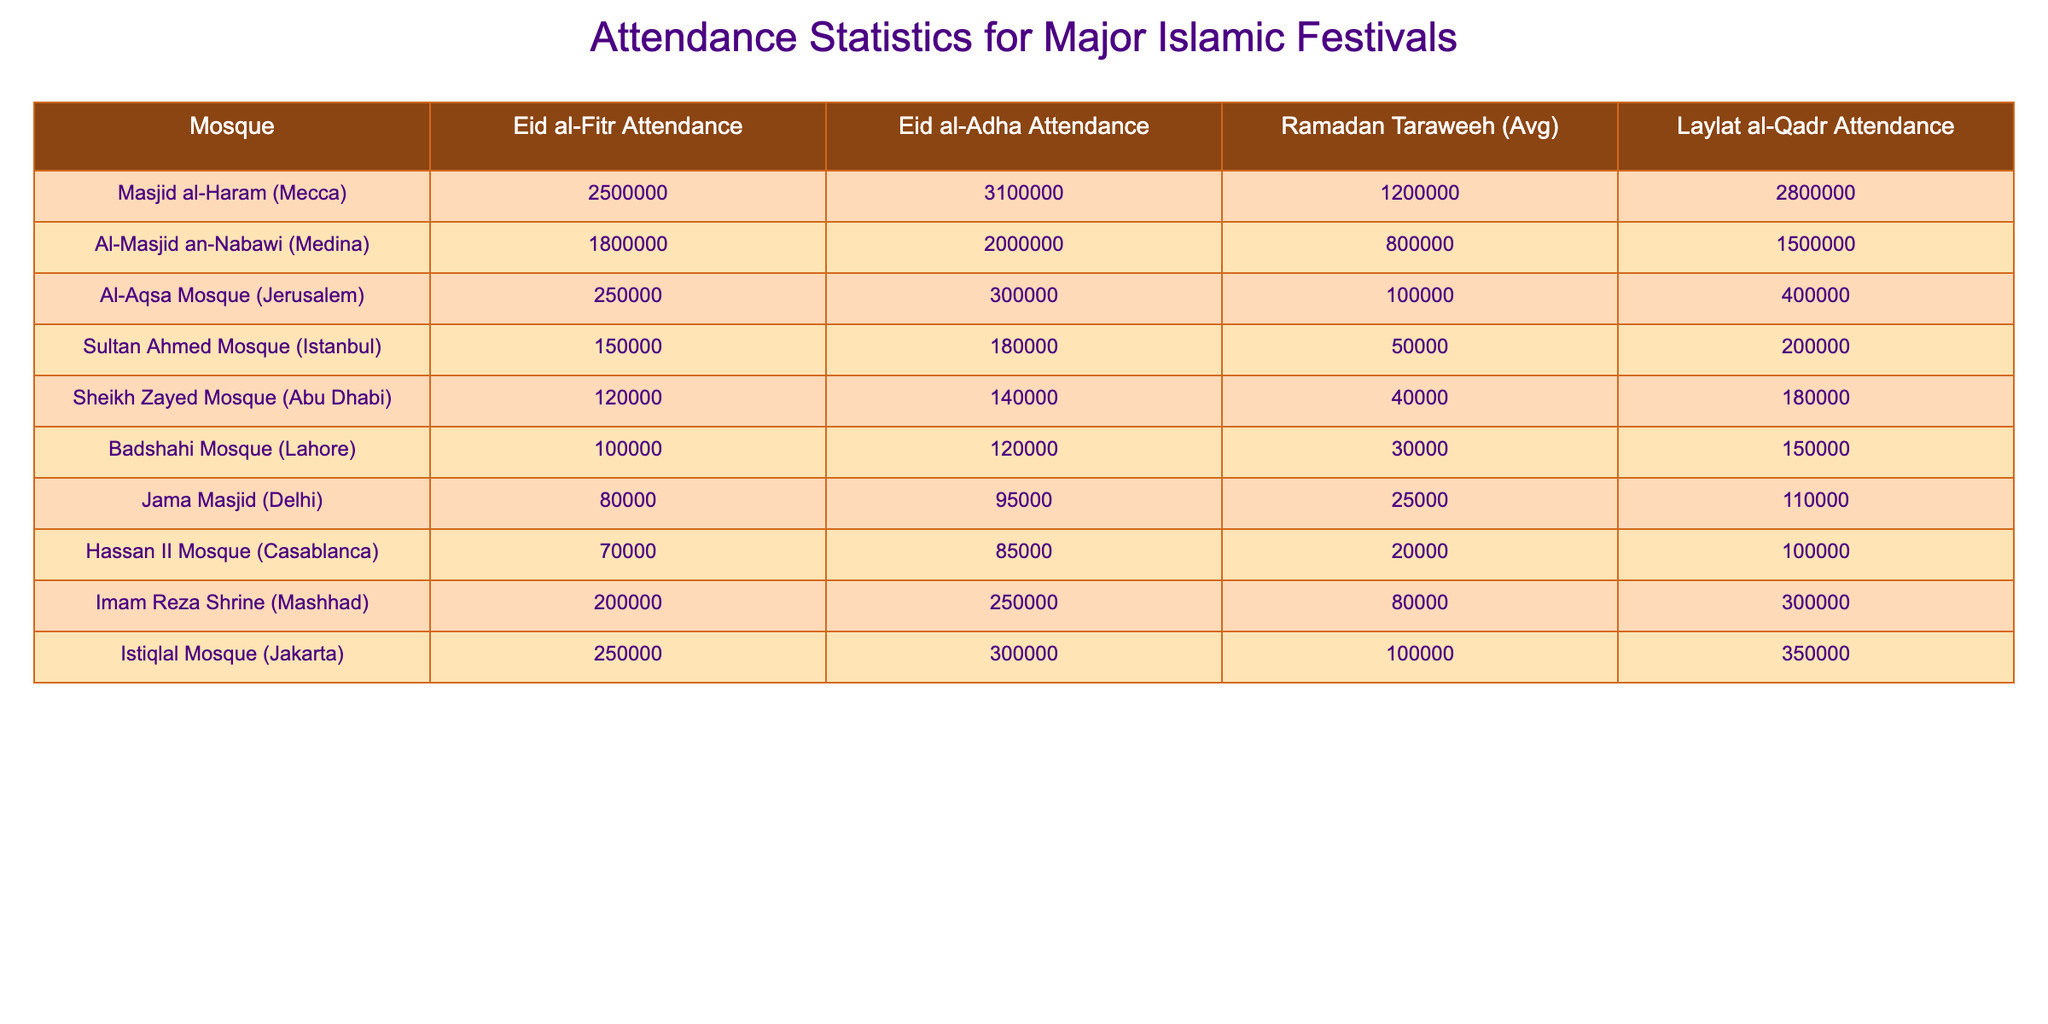What is the attendance for Eid al-Fitr at Masjid al-Haram? The attendance for Eid al-Fitr at Masjid al-Haram is directly listed in the table as 2,500,000.
Answer: 2,500,000 Which mosque had the highest attendance for Laylat al-Qadr? By comparing the values in the Laylat al-Qadr Attendance column, Masjid al-Haram has the highest attendance at 2,800,000.
Answer: Masjid al-Haram What is the total attendance for Eid al-Adha at the Badshahi Mosque and Jama Masjid? Adding the two values for Eid al-Adha Attendance: Badshahi Mosque (120,000) + Jama Masjid (95,000) = 215,000.
Answer: 215,000 How many attendees participated in Ramadan Taraweeh at the Istiqlal Mosque? The table shows the Ramadan Taraweeh average attendance for Istiqlal Mosque is 100,000.
Answer: 100,000 Is the attendance for Eid al-Fitr greater than for Eid al-Adha at Al-Masjid an-Nabawi? The table shows 1,800,000 for Eid al-Fitr and 2,000,000 for Eid al-Adha at Al-Masjid an-Nabawi. Therefore, Eid al-Fitr is not greater.
Answer: No What is the difference in Eid al-Adha attendance between Masjid al-Haram and Al-Aqsa Mosque? The difference is calculated by subtracting Al-Aqsa Mosque's attendance (300,000) from Masjid al-Haram's attendance (3,100,000): 3,100,000 - 300,000 = 2,800,000.
Answer: 2,800,000 Which mosque shows the lowest attendance for Laylat al-Qadr? Looking at the Laylat al-Qadr Attendance column, the lowest attendance is at Jama Masjid with 110,000 attendees.
Answer: Jama Masjid What is the average attendance for Eid al-Fitr across all mosques? To find the average, sum the Eid al-Fitr attendance of all mosques (2,500,000 + 1,800,000 + 250,000 + 150,000 + 120,000 + 100,000 + 80,000 + 70,000 + 200,000 + 250,000) = 5,520,000, and divide it by 10 (total mosques): 5,520,000 / 10 = 552,000.
Answer: 552,000 How does the attendance for Ramadan Taraweeh at Sheikh Zayed Mosque compare to that at Badshahi Mosque? The attendance for Ramadan Taraweeh at Sheikh Zayed Mosque is 40,000, and at Badshahi Mosque, it is 30,000, which means Sheikh Zayed Mosque has higher attendance.
Answer: Sheikh Zayed Mosque is higher 